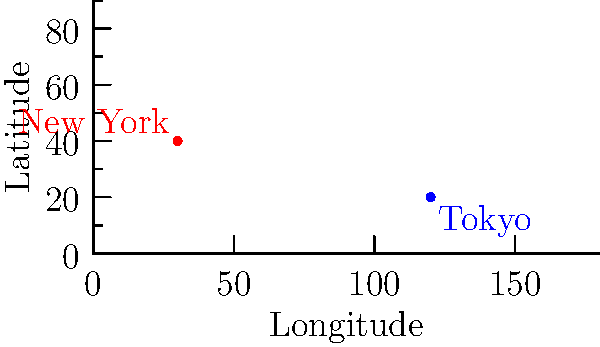As a diplomat working for an international organization, you need to calculate the distance between two capital cities for a global justice initiative. Given that New York City is located at coordinates (30°E, 40°N) and Tokyo is at (120°E, 20°N), calculate the approximate distance between these cities using the Euclidean distance formula. Assume the Earth is a perfect sphere with a radius of 6,371 km. Round your answer to the nearest kilometer. To solve this problem, we'll follow these steps:

1) First, we need to calculate the difference in coordinates:
   Difference in longitude: $\Delta \text{lon} = 120° - 30° = 90°$
   Difference in latitude: $\Delta \text{lat} = 20° - 40° = -20°$

2) Convert these differences to radians:
   $\Delta \text{lon}_{\text{rad}} = 90° \times \frac{\pi}{180°} = 1.5708 \text{ radians}$
   $\Delta \text{lat}_{\text{rad}} = -20° \times \frac{\pi}{180°} = -0.3491 \text{ radians}$

3) Use the Euclidean distance formula on a sphere (Haversine formula):
   $d = 2R \arcsin(\sqrt{\sin^2(\frac{\Delta \text{lat}}{2}) + \cos(\text{lat}_1) \cos(\text{lat}_2) \sin^2(\frac{\Delta \text{lon}}{2})})$

   Where:
   $R = 6371 \text{ km}$ (Earth's radius)
   $\text{lat}_1 = 40° \times \frac{\pi}{180°} = 0.6981 \text{ radians}$
   $\text{lat}_2 = 20° \times \frac{\pi}{180°} = 0.3491 \text{ radians}$

4) Plug in the values:
   $d = 2 \times 6371 \times \arcsin(\sqrt{\sin^2(\frac{-0.3491}{2}) + \cos(0.6981) \cos(0.3491) \sin^2(\frac{1.5708}{2})})$

5) Calculate:
   $d \approx 10,878.3 \text{ km}$

6) Rounding to the nearest kilometer:
   $d \approx 10,878 \text{ km}$
Answer: 10,878 km 